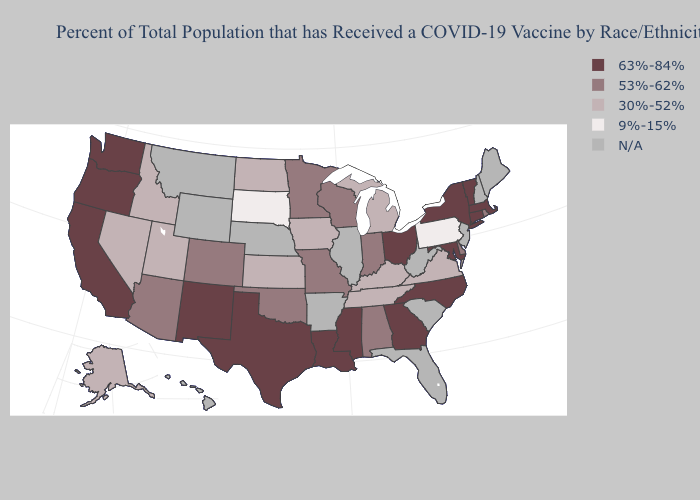Name the states that have a value in the range 30%-52%?
Answer briefly. Alaska, Idaho, Iowa, Kansas, Kentucky, Michigan, Nevada, North Dakota, Tennessee, Utah, Virginia. What is the lowest value in the South?
Be succinct. 30%-52%. Among the states that border Iowa , does Missouri have the lowest value?
Quick response, please. No. What is the value of New York?
Give a very brief answer. 63%-84%. Name the states that have a value in the range 9%-15%?
Keep it brief. Pennsylvania, South Dakota. Among the states that border South Dakota , does Iowa have the lowest value?
Write a very short answer. Yes. What is the highest value in the USA?
Quick response, please. 63%-84%. What is the value of North Carolina?
Write a very short answer. 63%-84%. Name the states that have a value in the range N/A?
Short answer required. Arkansas, Florida, Hawaii, Illinois, Maine, Montana, Nebraska, New Hampshire, New Jersey, South Carolina, West Virginia, Wyoming. Name the states that have a value in the range 53%-62%?
Be succinct. Alabama, Arizona, Colorado, Delaware, Indiana, Minnesota, Missouri, Oklahoma, Rhode Island, Wisconsin. Which states hav the highest value in the MidWest?
Answer briefly. Ohio. What is the value of Pennsylvania?
Write a very short answer. 9%-15%. Name the states that have a value in the range 30%-52%?
Answer briefly. Alaska, Idaho, Iowa, Kansas, Kentucky, Michigan, Nevada, North Dakota, Tennessee, Utah, Virginia. Among the states that border Maryland , which have the highest value?
Be succinct. Delaware. Among the states that border North Dakota , does Minnesota have the highest value?
Short answer required. Yes. 